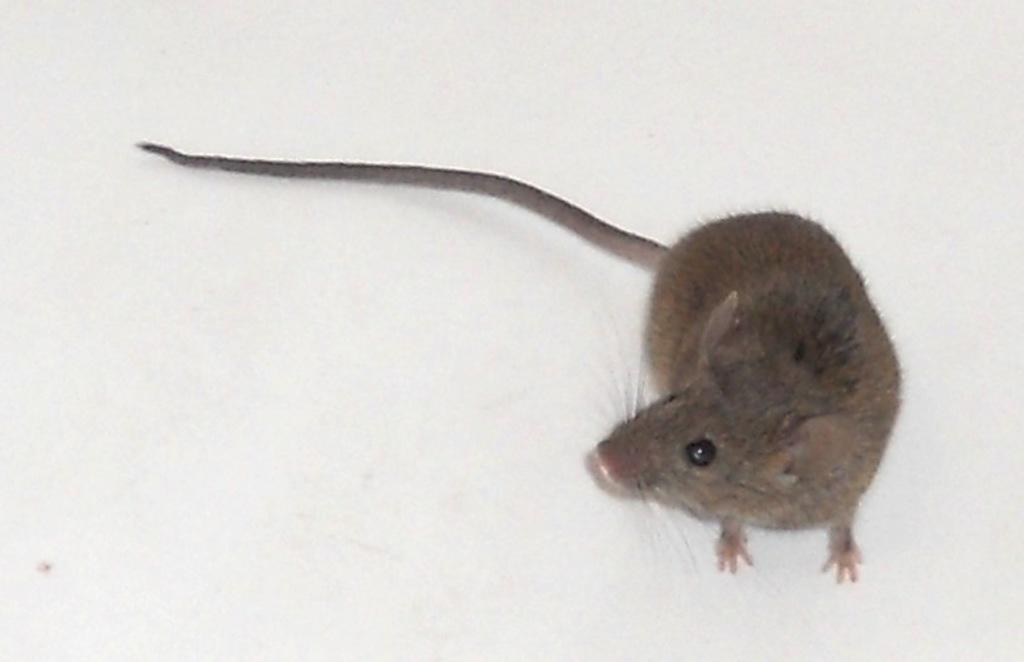What animal is present in the image? There is a rat in the image. What color is the background of the image? The background of the image is white. What type of stone is the rat using to power the engine in the image? There is no stone or engine present in the image; it features a rat with a white background. 